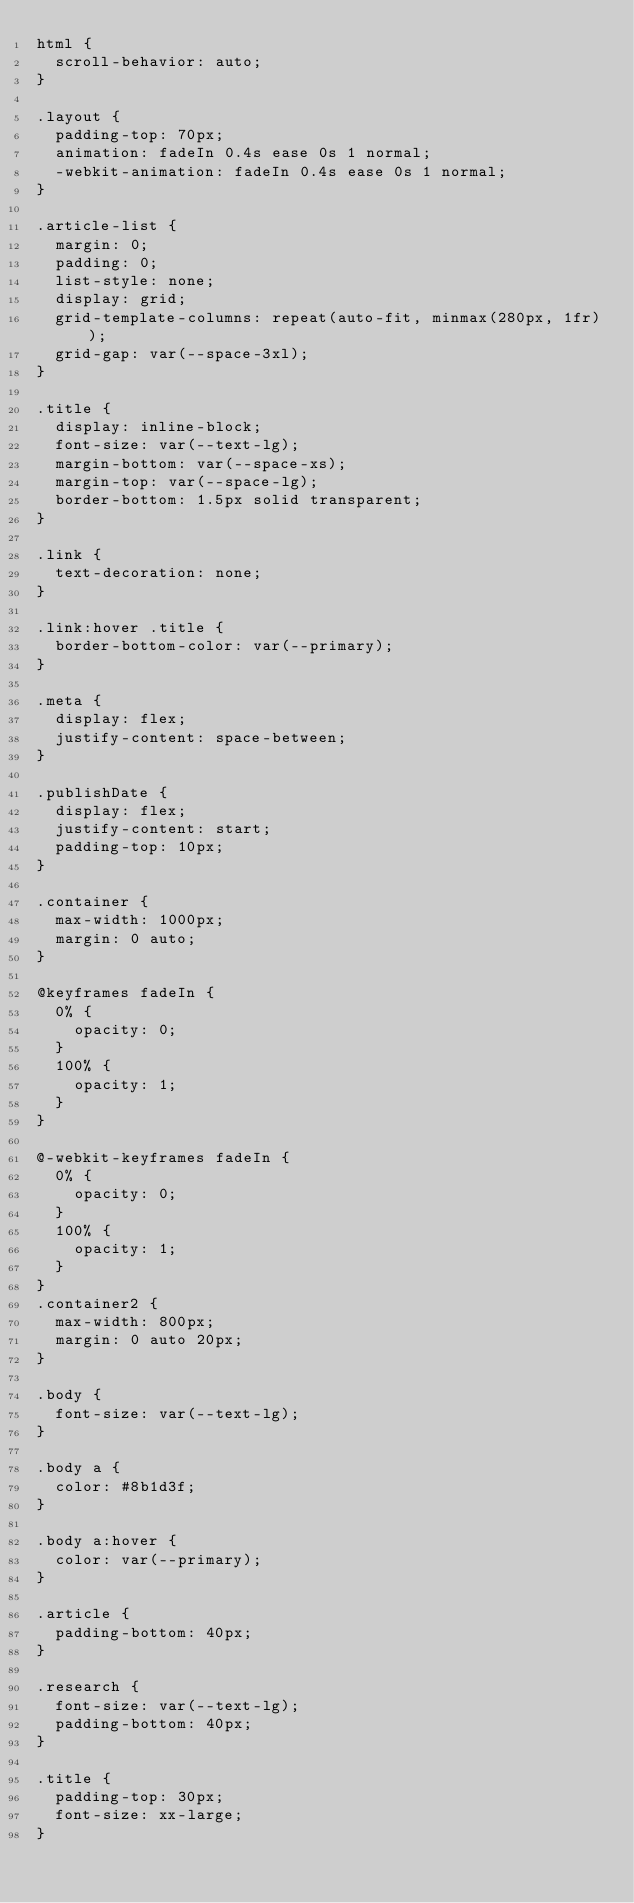<code> <loc_0><loc_0><loc_500><loc_500><_CSS_>html {
  scroll-behavior: auto;
}

.layout {
  padding-top: 70px;
  animation: fadeIn 0.4s ease 0s 1 normal;
  -webkit-animation: fadeIn 0.4s ease 0s 1 normal;
}

.article-list {
  margin: 0;
  padding: 0;
  list-style: none;
  display: grid;
  grid-template-columns: repeat(auto-fit, minmax(280px, 1fr));
  grid-gap: var(--space-3xl);
}

.title {
  display: inline-block;
  font-size: var(--text-lg);
  margin-bottom: var(--space-xs);
  margin-top: var(--space-lg);
  border-bottom: 1.5px solid transparent;
}

.link {
  text-decoration: none;
}

.link:hover .title {
  border-bottom-color: var(--primary);
}

.meta {
  display: flex;
  justify-content: space-between;
}

.publishDate {
  display: flex;
  justify-content: start;
  padding-top: 10px;
}

.container {
  max-width: 1000px;
  margin: 0 auto;
}

@keyframes fadeIn {
  0% {
    opacity: 0;
  }
  100% {
    opacity: 1;
  }
}

@-webkit-keyframes fadeIn {
  0% {
    opacity: 0;
  }
  100% {
    opacity: 1;
  }
}
.container2 {
  max-width: 800px;
  margin: 0 auto 20px;
}

.body {
  font-size: var(--text-lg);
}

.body a {
  color: #8b1d3f;
}

.body a:hover {
  color: var(--primary);
}

.article {
  padding-bottom: 40px;
}

.research {
  font-size: var(--text-lg);
  padding-bottom: 40px;
}

.title {
  padding-top: 30px;
  font-size: xx-large;
}
</code> 